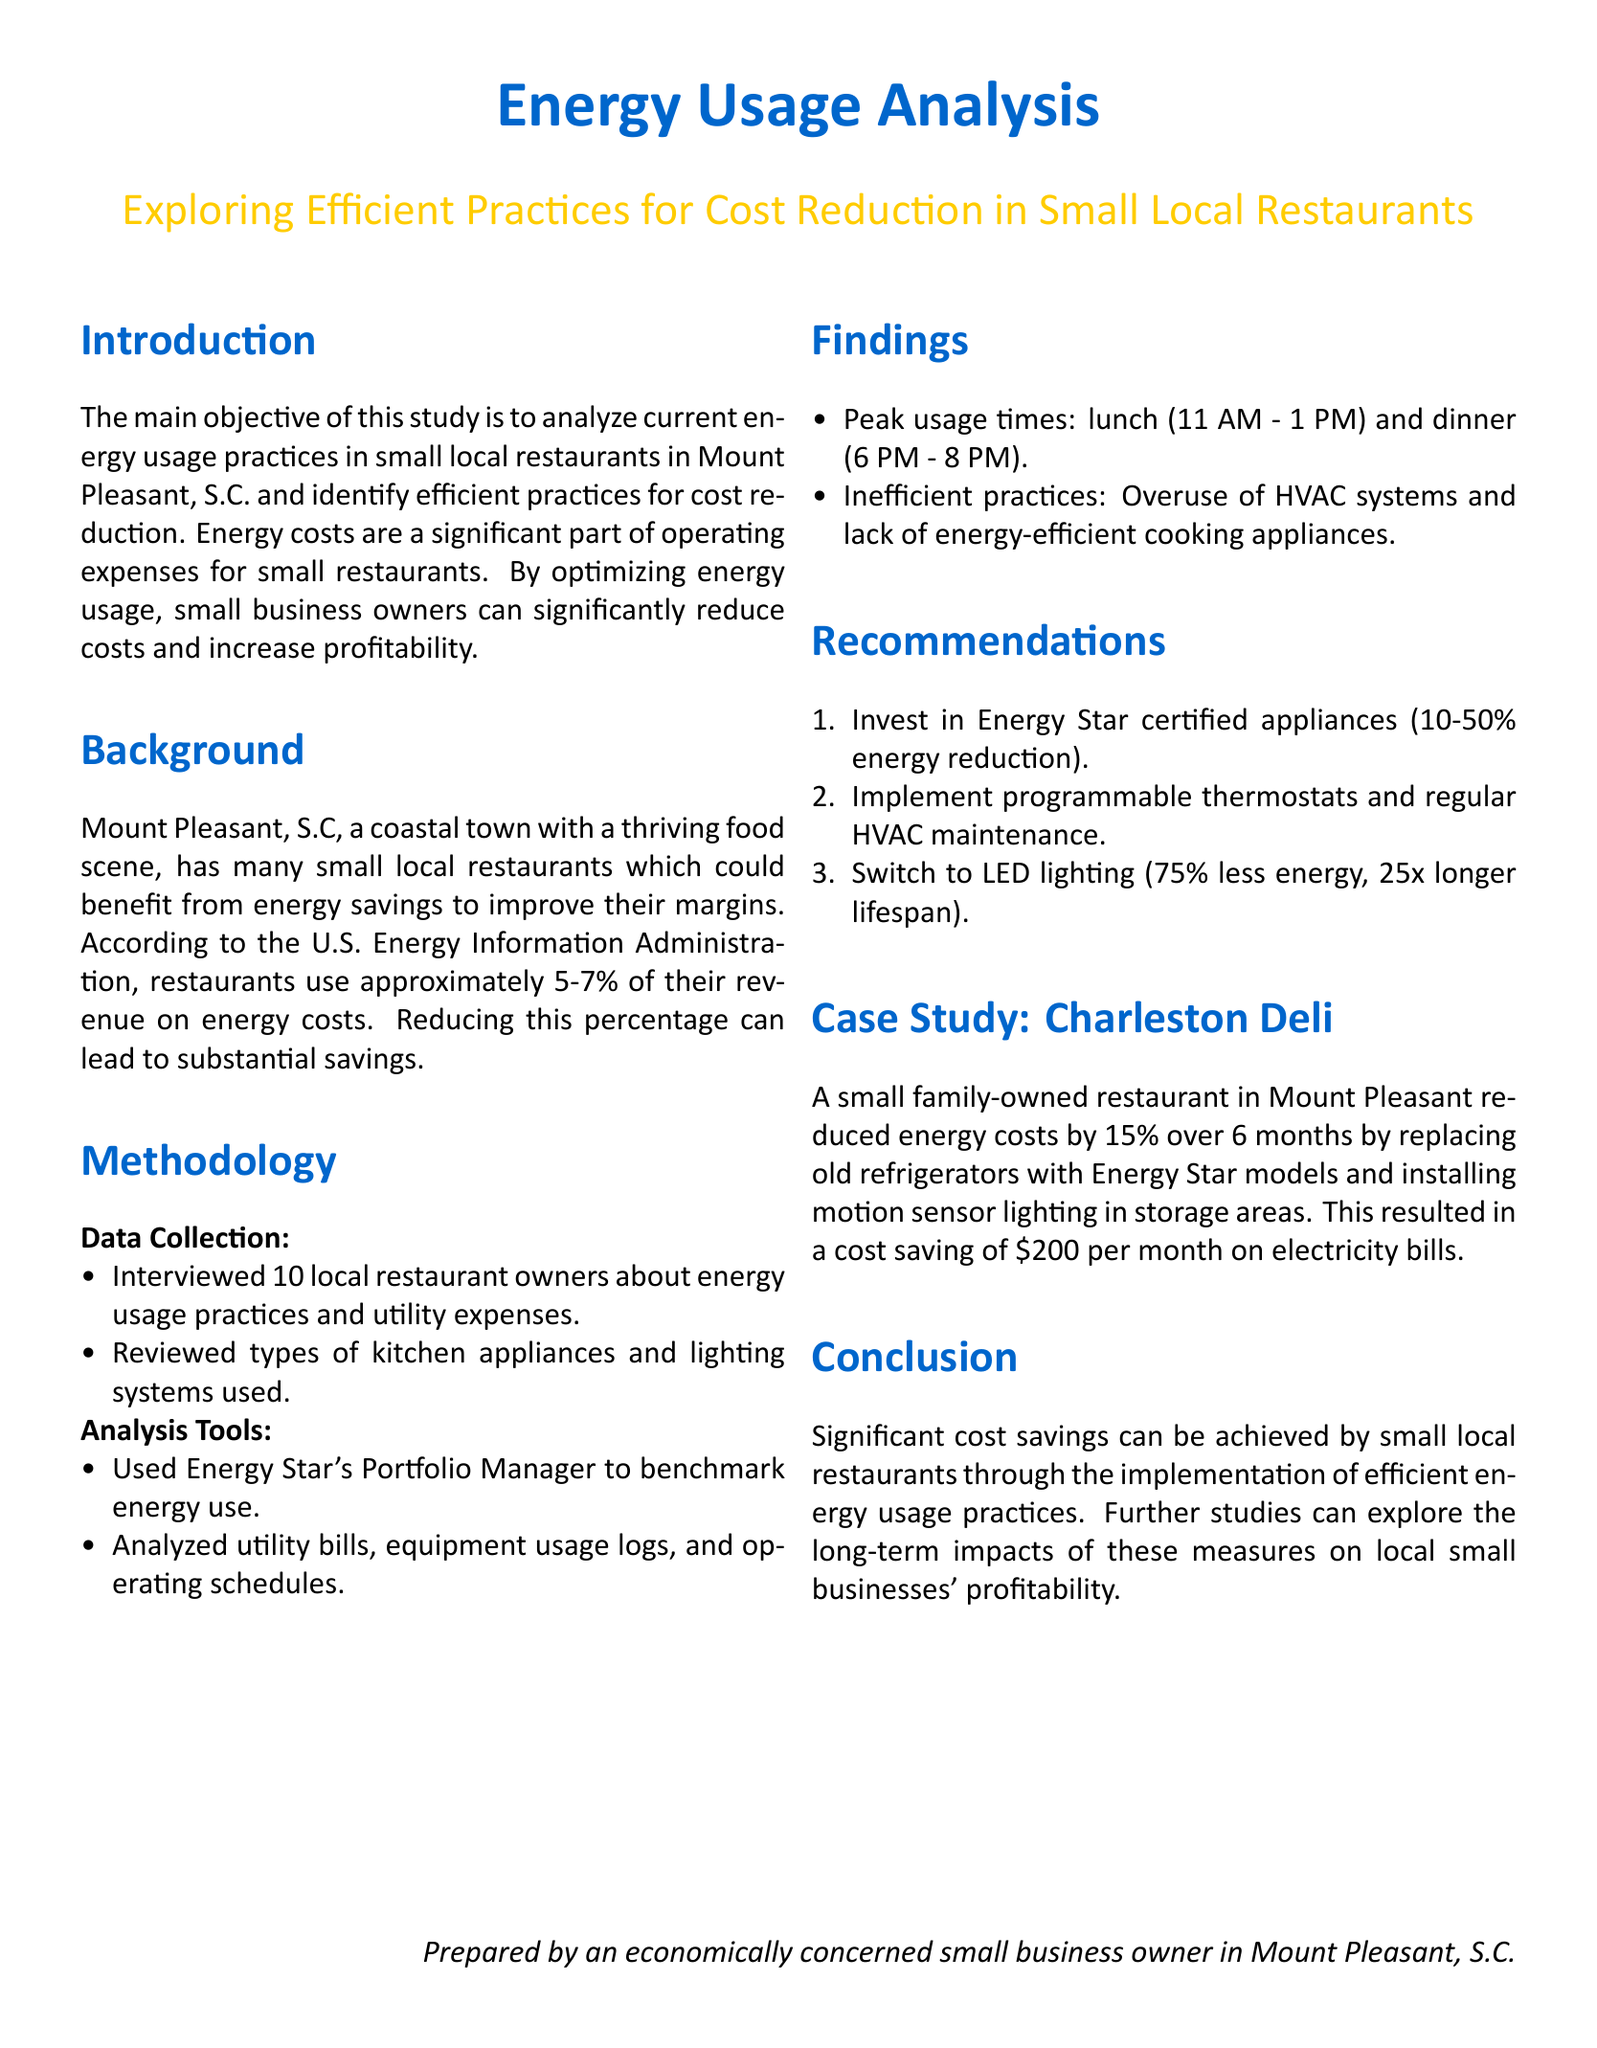What is the main objective of the study? The main objective is to analyze current energy usage practices in small local restaurants in Mount Pleasant, S.C. and identify efficient practices for cost reduction.
Answer: To analyze current energy usage practices What percentage of revenue do restaurants spend on energy costs? According to the U.S. Energy Information Administration, restaurants use approximately 5-7% of their revenue on energy costs.
Answer: 5-7% What appliance certification is recommended for energy reduction? The report recommends investing in Energy Star certified appliances, which can achieve 10-50% energy reduction.
Answer: Energy Star certified What was the monthly cost saving achieved by Charleston Deli? The Charleston Deli saved \$200 per month on electricity bills after implementing energy-efficient practices.
Answer: \$200 Which lighting system is suggested to switch to in the recommendations? The document suggests switching to LED lighting, which consumes 75% less energy.
Answer: LED lighting What were the peak usage times identified in the findings? Peak usage times were noted to be lunch (11 AM - 1 PM) and dinner (6 PM - 8 PM).
Answer: Lunch and dinner What method was used to benchmark energy use? Energy Star's Portfolio Manager was used to benchmark energy use.
Answer: Energy Star's Portfolio Manager How much did Charleston Deli reduce energy costs by over 6 months? Charleston Deli reduced energy costs by 15% over 6 months.
Answer: 15% What type of maintenance is recommended for HVAC systems? Regular HVAC maintenance is recommended in the report.
Answer: Regular HVAC maintenance 